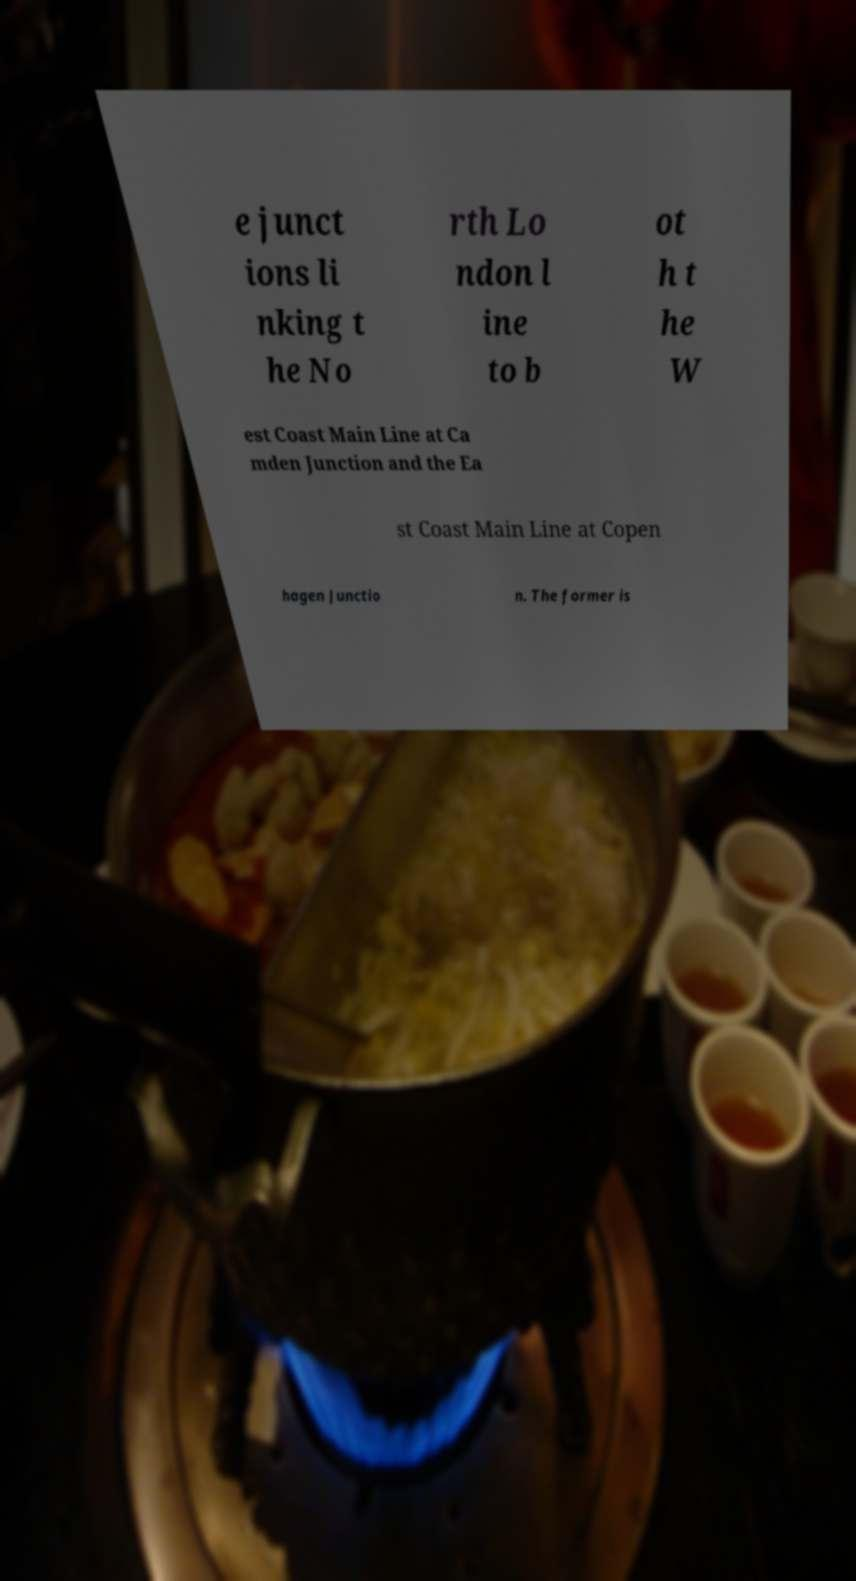For documentation purposes, I need the text within this image transcribed. Could you provide that? e junct ions li nking t he No rth Lo ndon l ine to b ot h t he W est Coast Main Line at Ca mden Junction and the Ea st Coast Main Line at Copen hagen Junctio n. The former is 